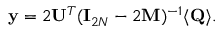Convert formula to latex. <formula><loc_0><loc_0><loc_500><loc_500>{ y } = 2 { U } ^ { T } ( { I } _ { 2 N } - 2 { M } ) ^ { - 1 } \langle { Q } \rangle .</formula> 